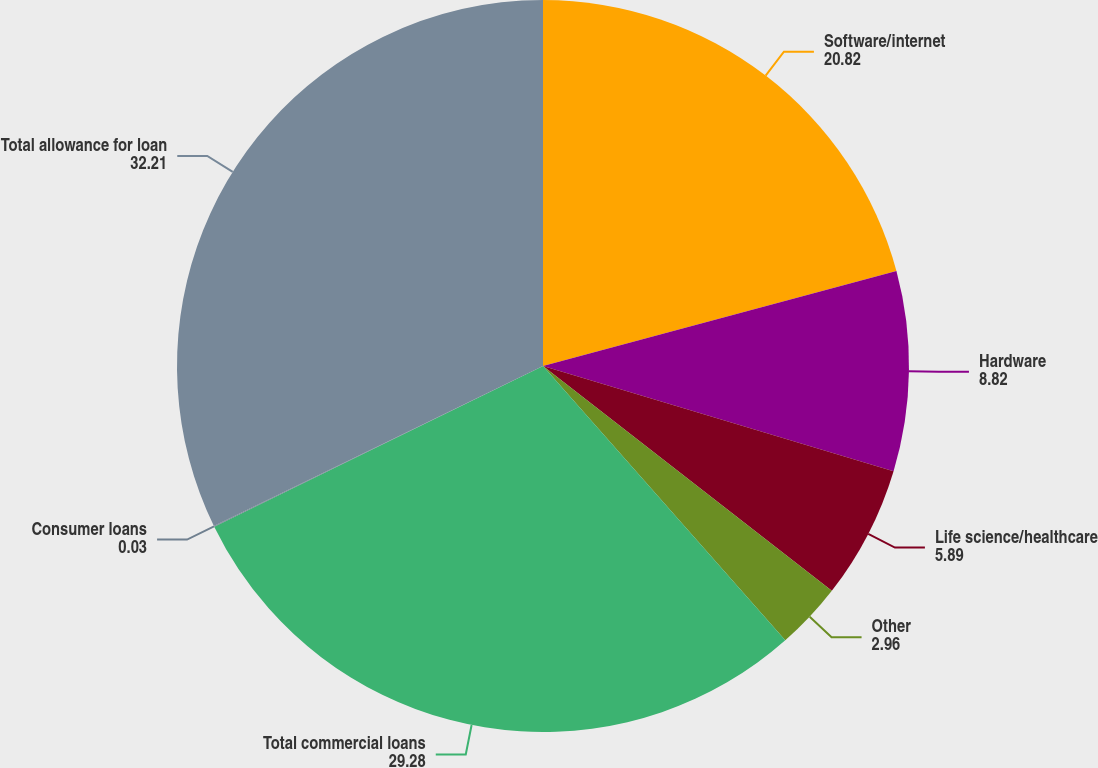<chart> <loc_0><loc_0><loc_500><loc_500><pie_chart><fcel>Software/internet<fcel>Hardware<fcel>Life science/healthcare<fcel>Other<fcel>Total commercial loans<fcel>Consumer loans<fcel>Total allowance for loan<nl><fcel>20.82%<fcel>8.82%<fcel>5.89%<fcel>2.96%<fcel>29.28%<fcel>0.03%<fcel>32.21%<nl></chart> 